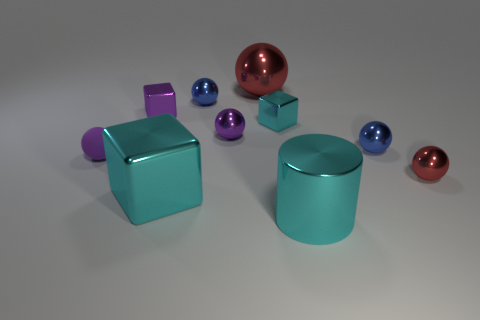Subtract 1 balls. How many balls are left? 5 Subtract all large balls. How many balls are left? 5 Subtract all brown balls. Subtract all yellow cylinders. How many balls are left? 6 Subtract all blocks. How many objects are left? 7 Subtract all cyan metallic cylinders. Subtract all large brown matte spheres. How many objects are left? 9 Add 8 rubber things. How many rubber things are left? 9 Add 6 tiny purple things. How many tiny purple things exist? 9 Subtract 1 cyan cubes. How many objects are left? 9 